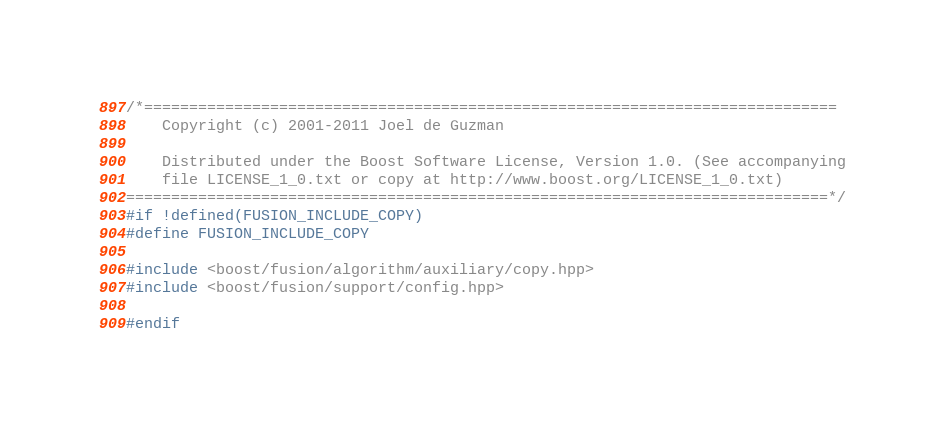Convert code to text. <code><loc_0><loc_0><loc_500><loc_500><_C++_>/*=============================================================================
    Copyright (c) 2001-2011 Joel de Guzman

    Distributed under the Boost Software License, Version 1.0. (See accompanying
    file LICENSE_1_0.txt or copy at http://www.boost.org/LICENSE_1_0.txt)
==============================================================================*/
#if !defined(FUSION_INCLUDE_COPY)
#define FUSION_INCLUDE_COPY

#include <boost/fusion/algorithm/auxiliary/copy.hpp>
#include <boost/fusion/support/config.hpp>

#endif
</code> 